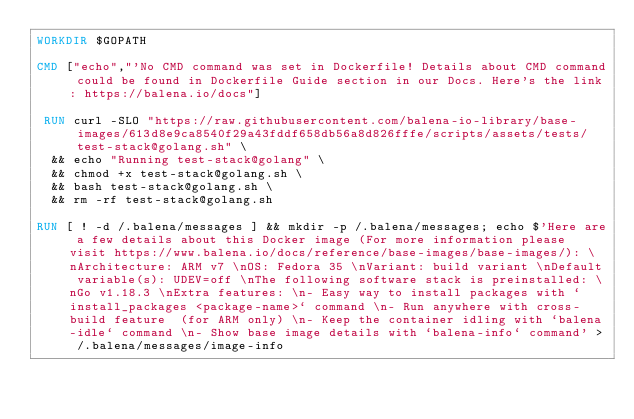Convert code to text. <code><loc_0><loc_0><loc_500><loc_500><_Dockerfile_>WORKDIR $GOPATH

CMD ["echo","'No CMD command was set in Dockerfile! Details about CMD command could be found in Dockerfile Guide section in our Docs. Here's the link: https://balena.io/docs"]

 RUN curl -SLO "https://raw.githubusercontent.com/balena-io-library/base-images/613d8e9ca8540f29a43fddf658db56a8d826fffe/scripts/assets/tests/test-stack@golang.sh" \
  && echo "Running test-stack@golang" \
  && chmod +x test-stack@golang.sh \
  && bash test-stack@golang.sh \
  && rm -rf test-stack@golang.sh 

RUN [ ! -d /.balena/messages ] && mkdir -p /.balena/messages; echo $'Here are a few details about this Docker image (For more information please visit https://www.balena.io/docs/reference/base-images/base-images/): \nArchitecture: ARM v7 \nOS: Fedora 35 \nVariant: build variant \nDefault variable(s): UDEV=off \nThe following software stack is preinstalled: \nGo v1.18.3 \nExtra features: \n- Easy way to install packages with `install_packages <package-name>` command \n- Run anywhere with cross-build feature  (for ARM only) \n- Keep the container idling with `balena-idle` command \n- Show base image details with `balena-info` command' > /.balena/messages/image-info</code> 